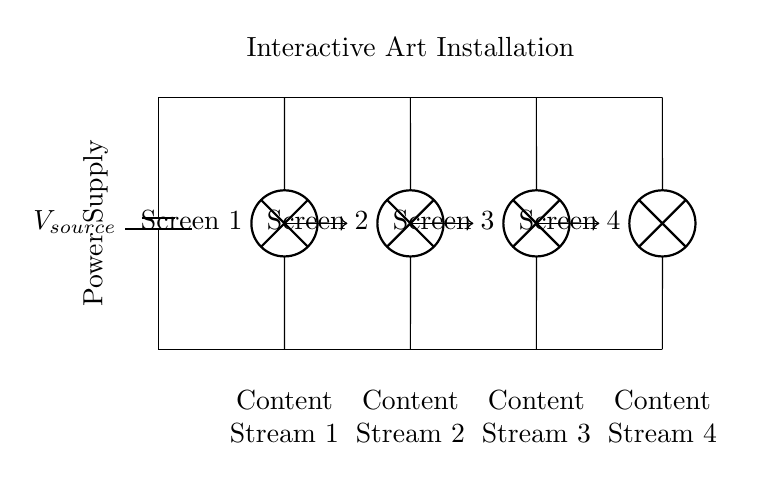What is the total number of screens in this installation? The circuit diagram shows four lamps labeled as Screen 1, Screen 2, Screen 3, and Screen 4, indicating that there are four screens.
Answer: four What type of circuit is depicted in the diagram? The diagram shows parallel connections where all components (screens) are connected across the same voltage source, allowing them to operate independently and receive the same voltage.
Answer: parallel What is the function of the battery in this circuit? The battery serves as the power supply providing the necessary voltage to all the connected screens in the installation.
Answer: power supply What does each screen receive in terms of electrical connection? Each screen is connected in parallel to the voltage source, allowing them to receive the same voltage independently while drawing different currents based on their individual properties.
Answer: same voltage How many content streams are illustrated in the circuit? The diagram indicates four distinct content streams associated with each screen, labeled beneath each lamp (Screen 1 through Screen 4).
Answer: four What would happen if one screen fails in this parallel circuit? In a parallel circuit configuration, if one screen fails, the remaining screens will continue to operate since they are independently connected to the voltage source.
Answer: others continue to operate What is the significance of having a parallel arrangement in this art installation? A parallel arrangement in this context allows each screen to function independently; if one fails, it does not affect the functionality of the others, maintaining the overall experience of the installation.
Answer: independent functionality 